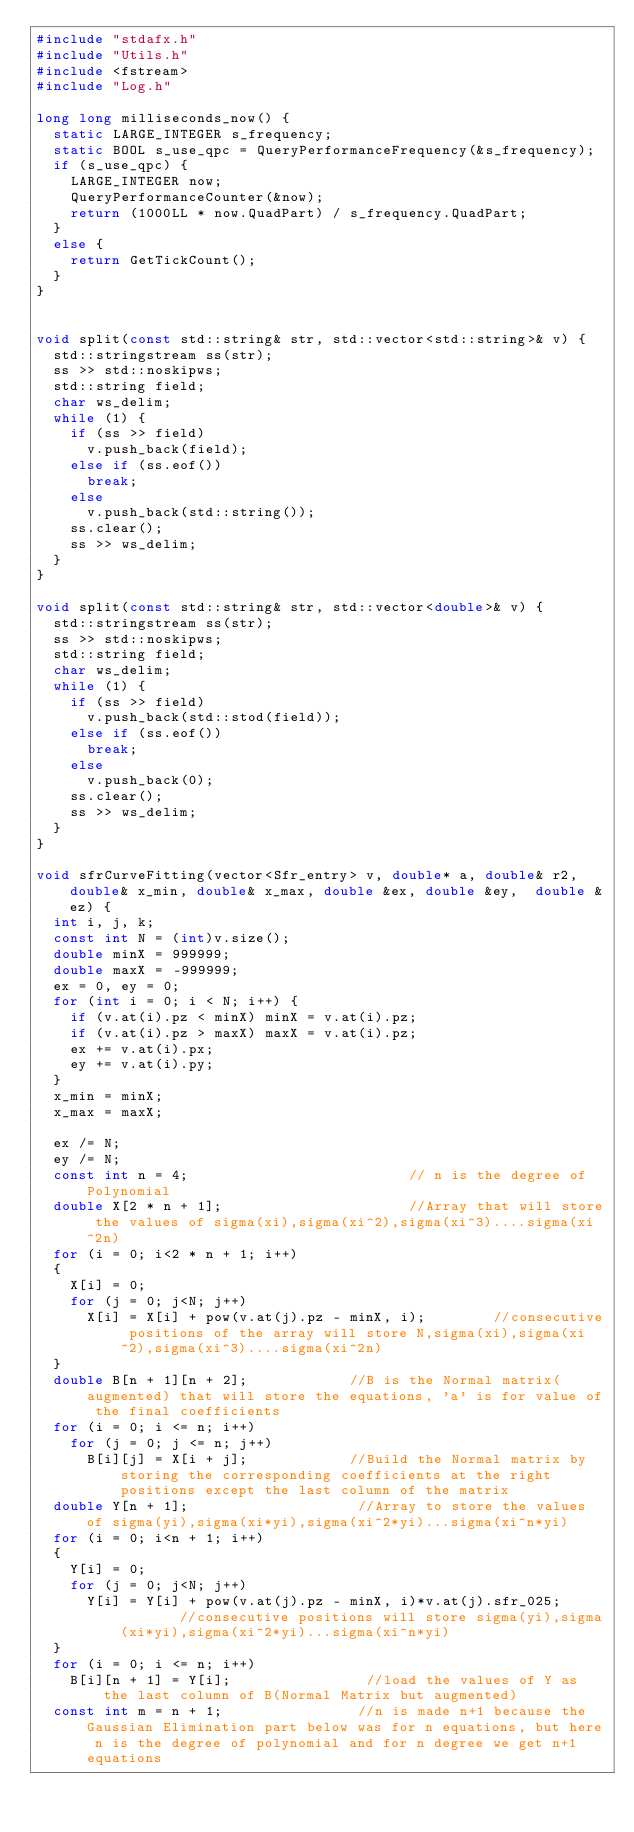<code> <loc_0><loc_0><loc_500><loc_500><_C++_>#include "stdafx.h"
#include "Utils.h"
#include <fstream>
#include "Log.h"

long long milliseconds_now() {
	static LARGE_INTEGER s_frequency;
	static BOOL s_use_qpc = QueryPerformanceFrequency(&s_frequency);
	if (s_use_qpc) {
		LARGE_INTEGER now;
		QueryPerformanceCounter(&now);
		return (1000LL * now.QuadPart) / s_frequency.QuadPart;
	}
	else {
		return GetTickCount();
	}
}


void split(const std::string& str, std::vector<std::string>& v) {
	std::stringstream ss(str);
	ss >> std::noskipws;
	std::string field;
	char ws_delim;
	while (1) {
		if (ss >> field)
			v.push_back(field);
		else if (ss.eof())
			break;
		else
			v.push_back(std::string());
		ss.clear();
		ss >> ws_delim;
	}
}

void split(const std::string& str, std::vector<double>& v) {
	std::stringstream ss(str);
	ss >> std::noskipws;
	std::string field;
	char ws_delim;
	while (1) {
		if (ss >> field)
			v.push_back(std::stod(field));
		else if (ss.eof())
			break;
		else
			v.push_back(0);
		ss.clear();
		ss >> ws_delim;
	}
}

void sfrCurveFitting(vector<Sfr_entry> v, double* a, double& r2, double& x_min, double& x_max, double &ex, double &ey,  double &ez) {
	int i, j, k;
	const int N = (int)v.size();
	double minX = 999999;
	double maxX = -999999;
	ex = 0, ey = 0; 
	for (int i = 0; i < N; i++) {
		if (v.at(i).pz < minX) minX = v.at(i).pz;
		if (v.at(i).pz > maxX) maxX = v.at(i).pz;
		ex += v.at(i).px;
		ey += v.at(i).py;
	}
	x_min = minX;
	x_max = maxX;

	ex /= N;
	ey /= N;
	const int n = 4;                          // n is the degree of Polynomial    
	double X[2 * n + 1];                      //Array that will store the values of sigma(xi),sigma(xi^2),sigma(xi^3)....sigma(xi^2n)
	for (i = 0; i<2 * n + 1; i++)
	{
		X[i] = 0;
		for (j = 0; j<N; j++)
			X[i] = X[i] + pow(v.at(j).pz - minX, i);        //consecutive positions of the array will store N,sigma(xi),sigma(xi^2),sigma(xi^3)....sigma(xi^2n)
	}
	double B[n + 1][n + 2];            //B is the Normal matrix(augmented) that will store the equations, 'a' is for value of the final coefficients
	for (i = 0; i <= n; i++)
		for (j = 0; j <= n; j++)
			B[i][j] = X[i + j];            //Build the Normal matrix by storing the corresponding coefficients at the right positions except the last column of the matrix
	double Y[n + 1];                    //Array to store the values of sigma(yi),sigma(xi*yi),sigma(xi^2*yi)...sigma(xi^n*yi)
	for (i = 0; i<n + 1; i++)
	{
		Y[i] = 0;
		for (j = 0; j<N; j++)
			Y[i] = Y[i] + pow(v.at(j).pz - minX, i)*v.at(j).sfr_025;        //consecutive positions will store sigma(yi),sigma(xi*yi),sigma(xi^2*yi)...sigma(xi^n*yi)
	}
	for (i = 0; i <= n; i++)
		B[i][n + 1] = Y[i];                //load the values of Y as the last column of B(Normal Matrix but augmented)
	const int m = n + 1;                //n is made n+1 because the Gaussian Elimination part below was for n equations, but here n is the degree of polynomial and for n degree we get n+1 equations</code> 